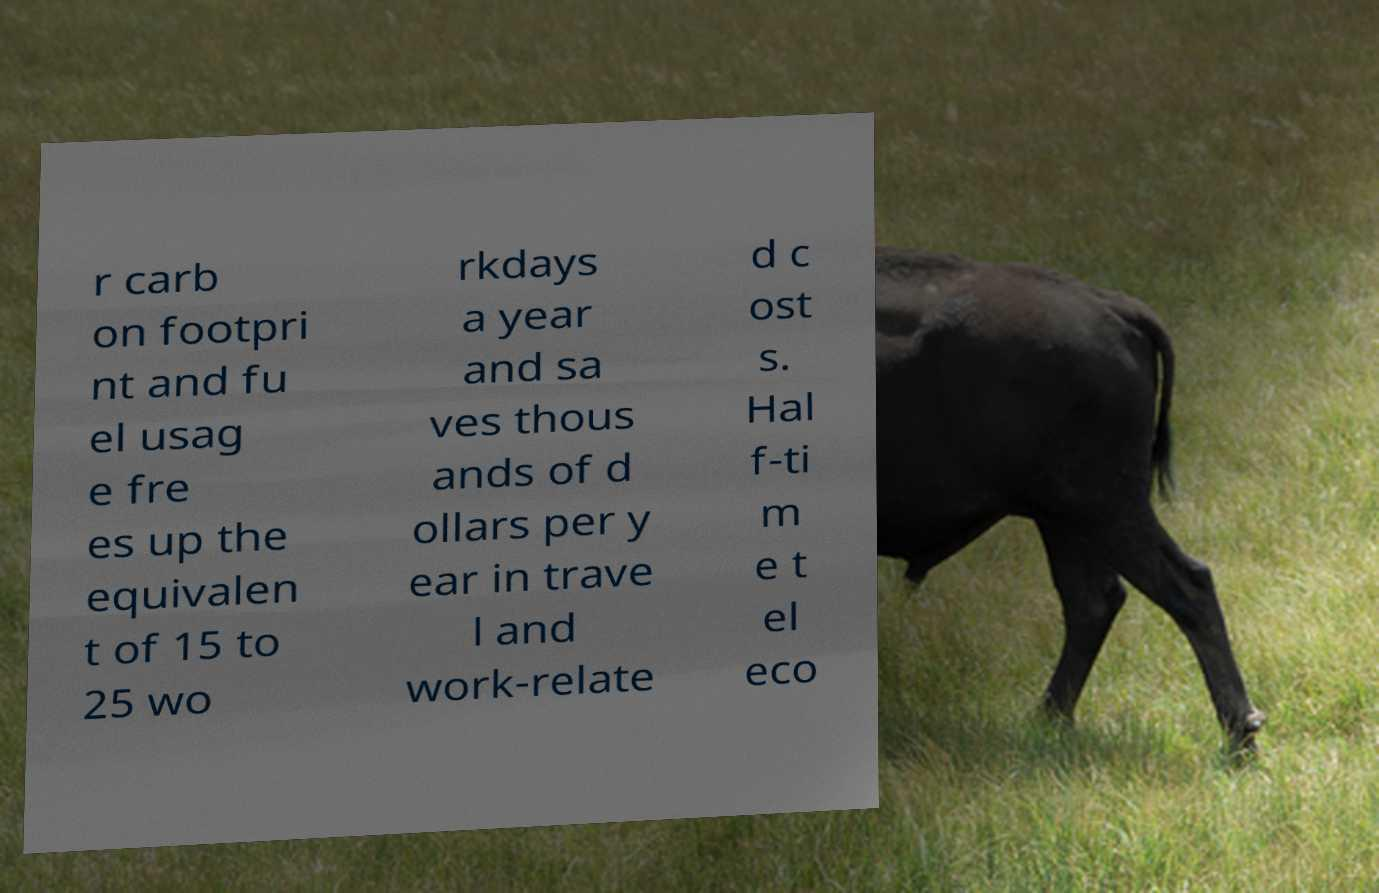Could you extract and type out the text from this image? r carb on footpri nt and fu el usag e fre es up the equivalen t of 15 to 25 wo rkdays a year and sa ves thous ands of d ollars per y ear in trave l and work-relate d c ost s. Hal f-ti m e t el eco 